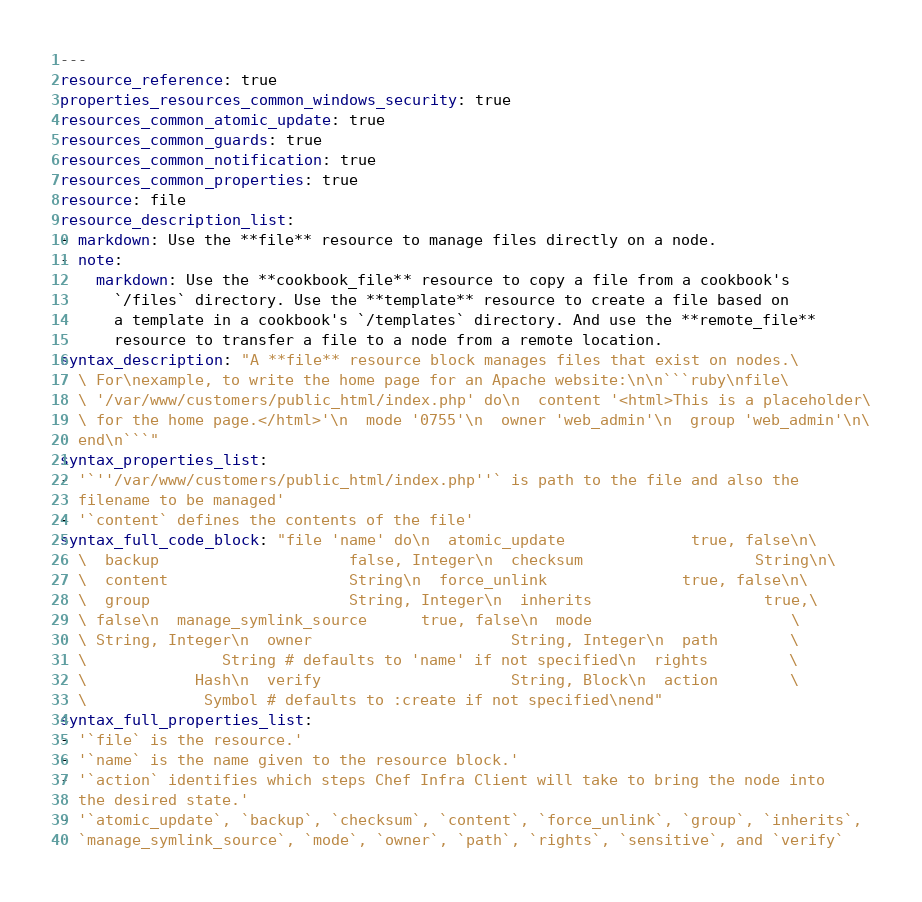<code> <loc_0><loc_0><loc_500><loc_500><_YAML_>---
resource_reference: true
properties_resources_common_windows_security: true
resources_common_atomic_update: true
resources_common_guards: true
resources_common_notification: true
resources_common_properties: true
resource: file
resource_description_list:
- markdown: Use the **file** resource to manage files directly on a node.
- note:
    markdown: Use the **cookbook_file** resource to copy a file from a cookbook's
      `/files` directory. Use the **template** resource to create a file based on
      a template in a cookbook's `/templates` directory. And use the **remote_file**
      resource to transfer a file to a node from a remote location.
syntax_description: "A **file** resource block manages files that exist on nodes.\
  \ For\nexample, to write the home page for an Apache website:\n\n```ruby\nfile\
  \ '/var/www/customers/public_html/index.php' do\n  content '<html>This is a placeholder\
  \ for the home page.</html>'\n  mode '0755'\n  owner 'web_admin'\n  group 'web_admin'\n\
  end\n```"
syntax_properties_list:
- '`''/var/www/customers/public_html/index.php''` is path to the file and also the
  filename to be managed'
- '`content` defines the contents of the file'
syntax_full_code_block: "file 'name' do\n  atomic_update              true, false\n\
  \  backup                     false, Integer\n  checksum                   String\n\
  \  content                    String\n  force_unlink               true, false\n\
  \  group                      String, Integer\n  inherits                   true,\
  \ false\n  manage_symlink_source      true, false\n  mode                      \
  \ String, Integer\n  owner                      String, Integer\n  path        \
  \               String # defaults to 'name' if not specified\n  rights         \
  \            Hash\n  verify                     String, Block\n  action        \
  \             Symbol # defaults to :create if not specified\nend"
syntax_full_properties_list:
- '`file` is the resource.'
- '`name` is the name given to the resource block.'
- '`action` identifies which steps Chef Infra Client will take to bring the node into
  the desired state.'
- '`atomic_update`, `backup`, `checksum`, `content`, `force_unlink`, `group`, `inherits`,
  `manage_symlink_source`, `mode`, `owner`, `path`, `rights`, `sensitive`, and `verify`</code> 